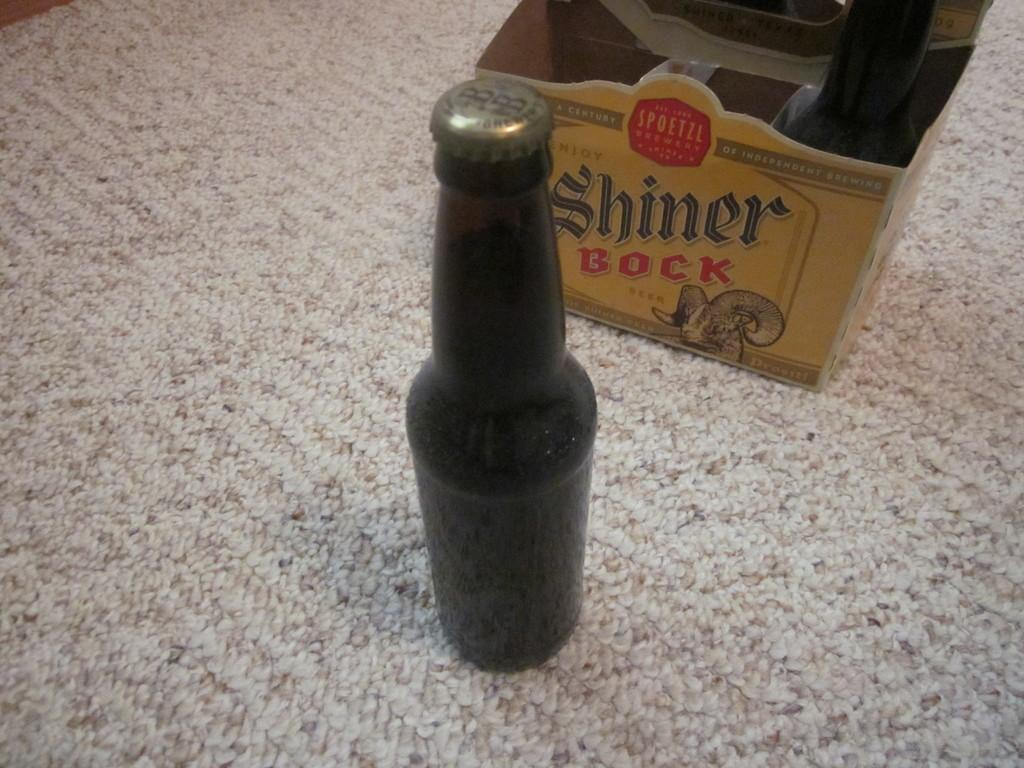Provide a one-sentence caption for the provided image. Two bottles of Shiner Bock's beer on the carpet. 